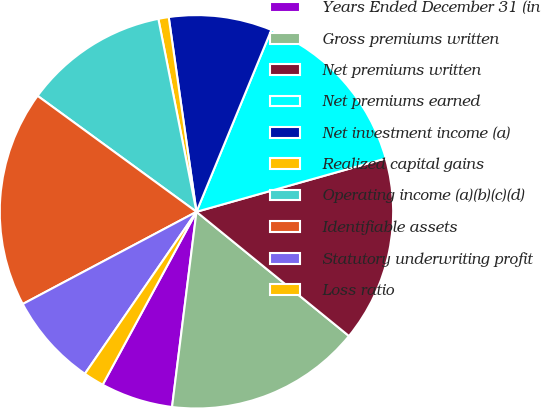Convert chart. <chart><loc_0><loc_0><loc_500><loc_500><pie_chart><fcel>Years Ended December 31 (in<fcel>Gross premiums written<fcel>Net premiums written<fcel>Net premiums earned<fcel>Net investment income (a)<fcel>Realized capital gains<fcel>Operating income (a)(b)(c)(d)<fcel>Identifiable assets<fcel>Statutory underwriting profit<fcel>Loss ratio<nl><fcel>5.93%<fcel>16.1%<fcel>15.25%<fcel>14.41%<fcel>8.47%<fcel>0.85%<fcel>11.86%<fcel>17.8%<fcel>7.63%<fcel>1.69%<nl></chart> 